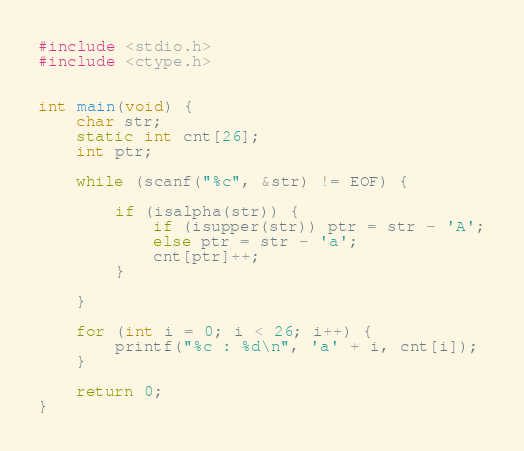Convert code to text. <code><loc_0><loc_0><loc_500><loc_500><_C++_>#include <stdio.h>
#include <ctype.h>


int main(void) {
	char str;
	static int cnt[26];
	int ptr;

	while (scanf("%c", &str) != EOF) {

		if (isalpha(str)) {
			if (isupper(str)) ptr = str - 'A';
			else ptr = str - 'a';
			cnt[ptr]++;
		}

	}

	for (int i = 0; i < 26; i++) {
		printf("%c : %d\n", 'a' + i, cnt[i]);
	}
	
	return 0;
}</code> 